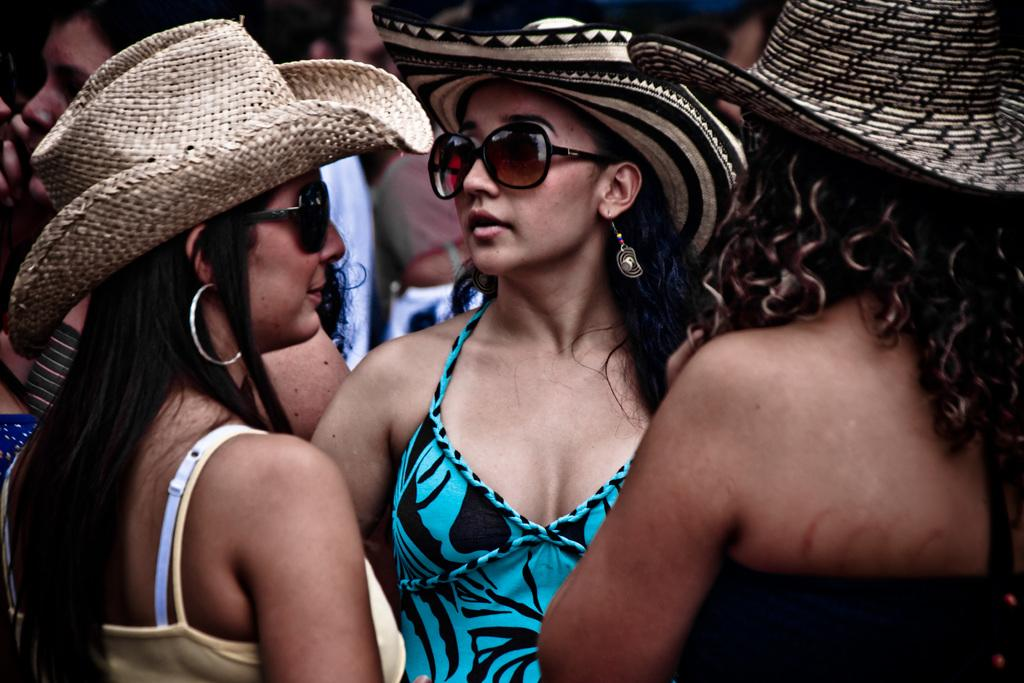What is the main subject of the image? The main subject of the image is women standing. Can you describe any accessories the women are wearing? Some of the women are wearing sunglasses, and three women are wearing hats. What type of picture is hanging on the wall behind the women in the image? There is no information about a picture hanging on the wall behind the women in the image. 